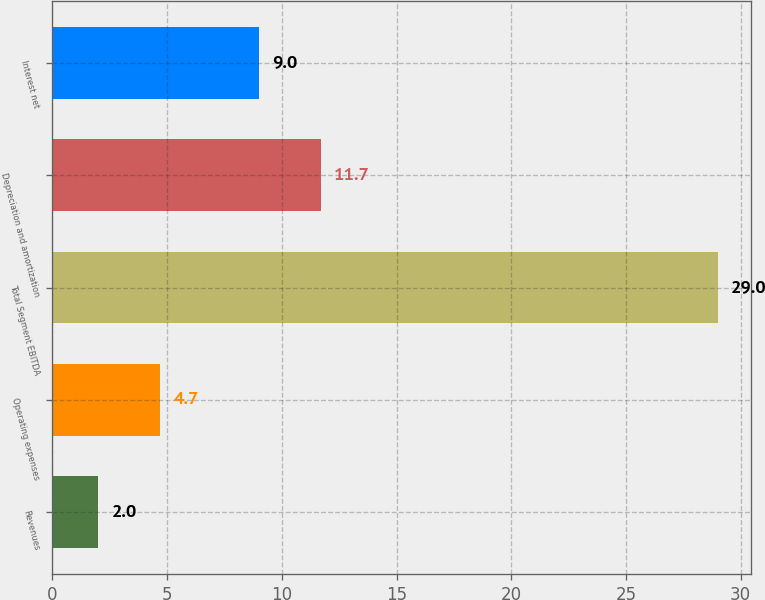Convert chart to OTSL. <chart><loc_0><loc_0><loc_500><loc_500><bar_chart><fcel>Revenues<fcel>Operating expenses<fcel>Total Segment EBITDA<fcel>Depreciation and amortization<fcel>Interest net<nl><fcel>2<fcel>4.7<fcel>29<fcel>11.7<fcel>9<nl></chart> 